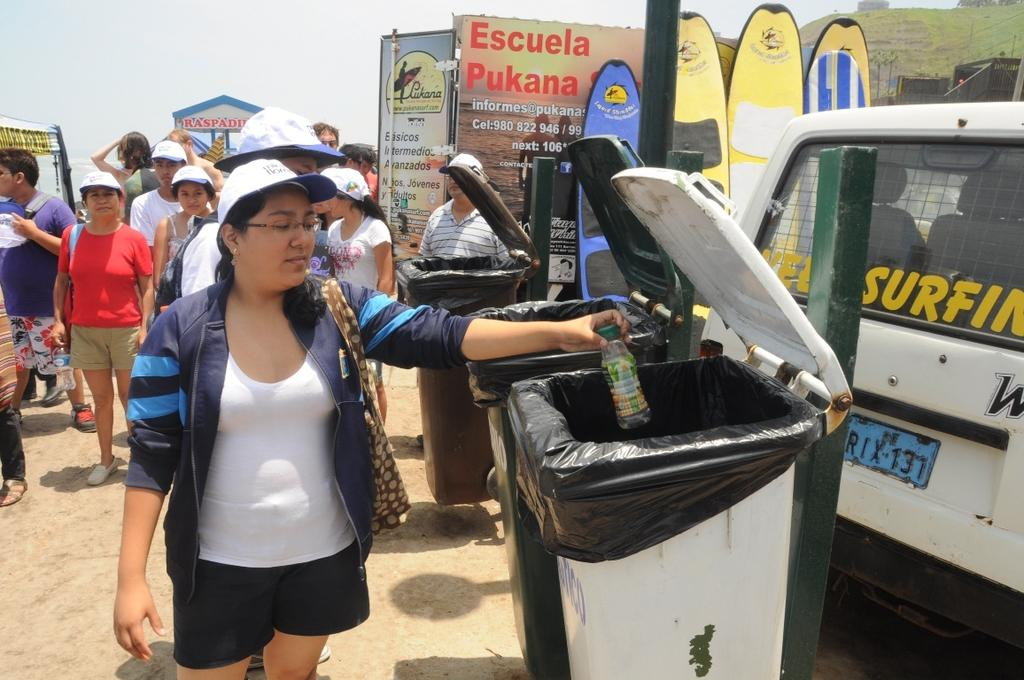<image>
Offer a succinct explanation of the picture presented. A woman is throwing away a bottle in the trash, in front of a banner that says "Escuela Pukana." 